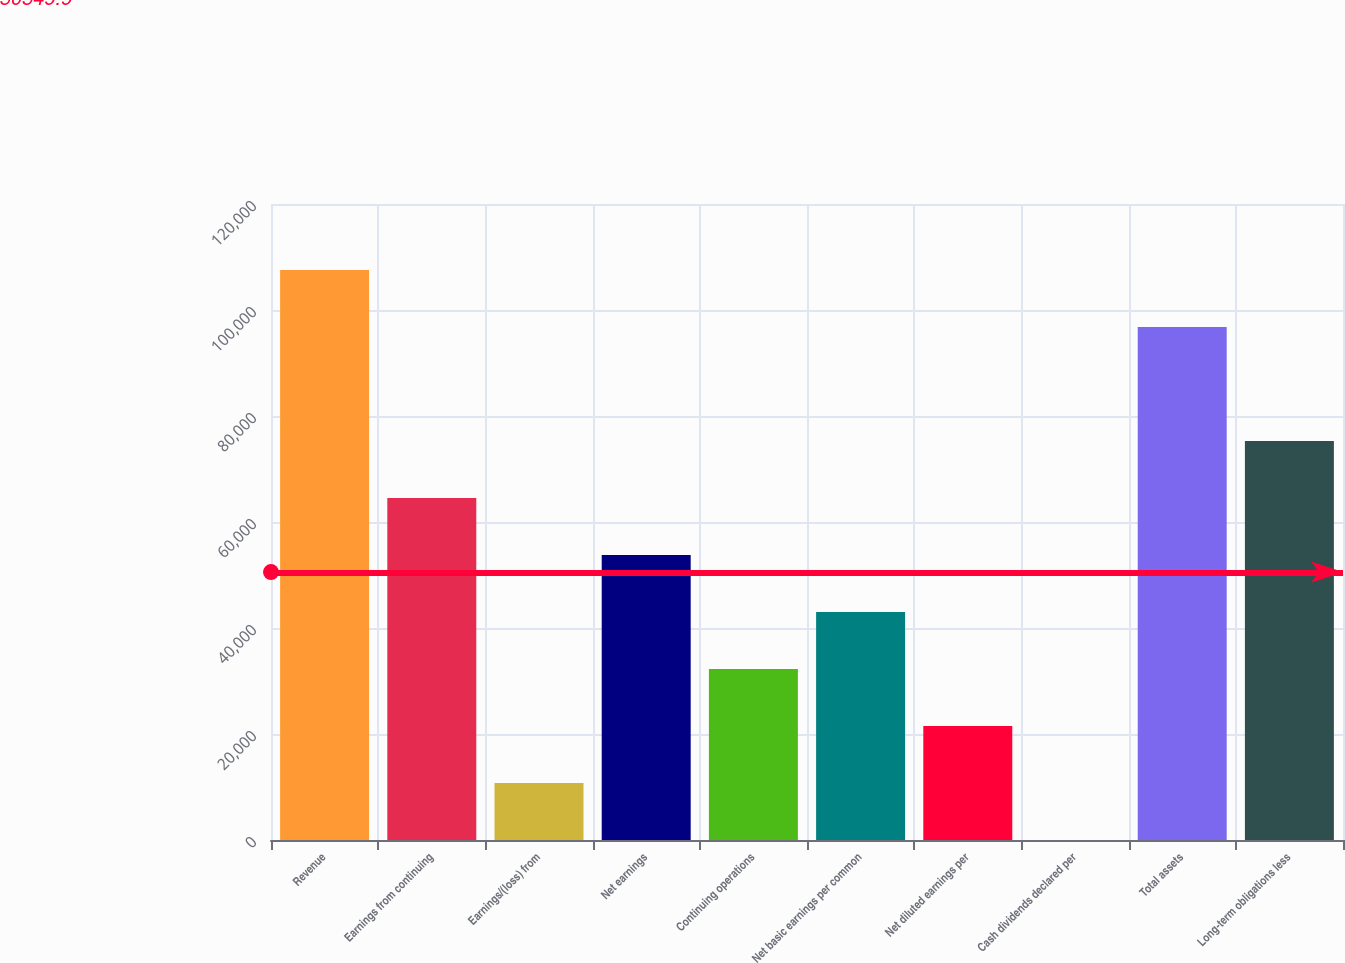<chart> <loc_0><loc_0><loc_500><loc_500><bar_chart><fcel>Revenue<fcel>Earnings from continuing<fcel>Earnings/(loss) from<fcel>Net earnings<fcel>Continuing operations<fcel>Net basic earnings per common<fcel>Net diluted earnings per<fcel>Cash dividends declared per<fcel>Total assets<fcel>Long-term obligations less<nl><fcel>107552<fcel>64531.5<fcel>10756<fcel>53776.4<fcel>32266.2<fcel>43021.3<fcel>21511.1<fcel>0.88<fcel>96796.9<fcel>75286.6<nl></chart> 